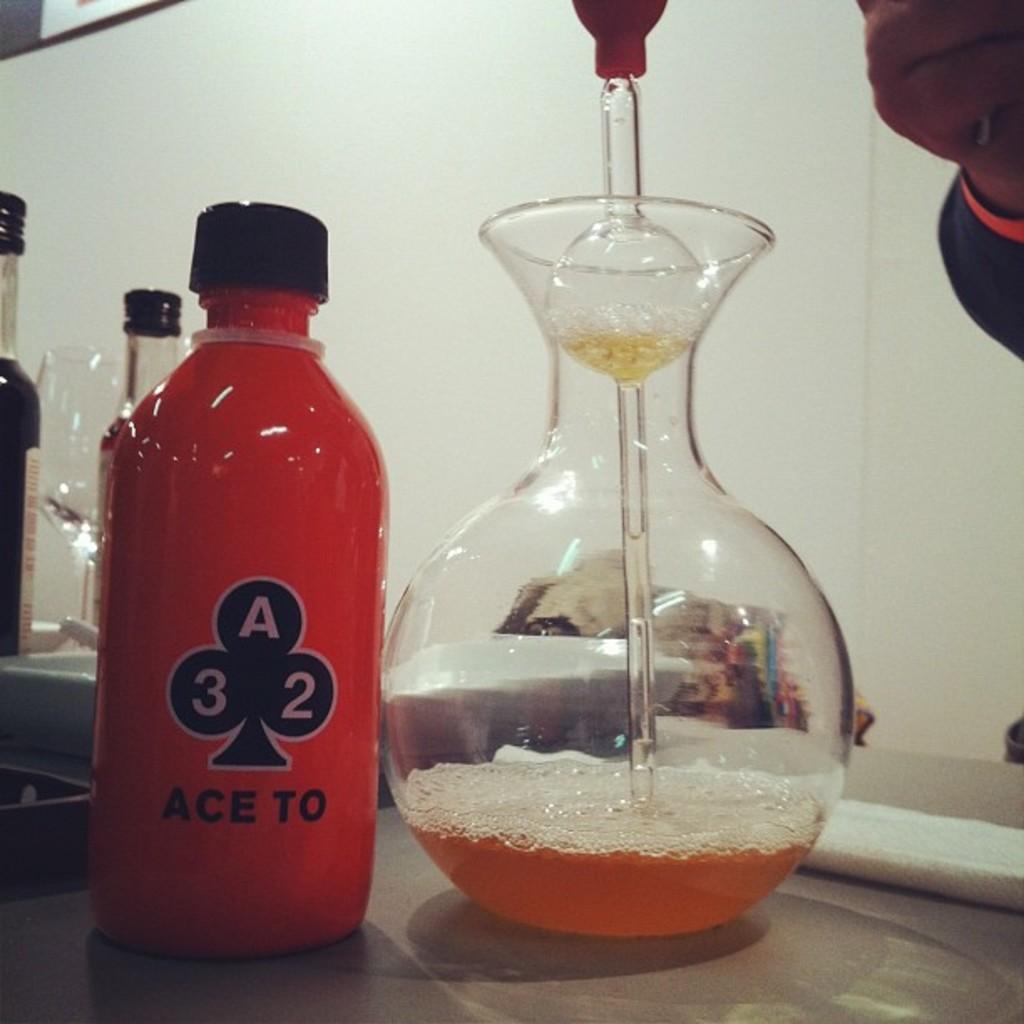In one or two sentences, can you explain what this image depicts? In this image there is a bottle and glass on top of the table. 